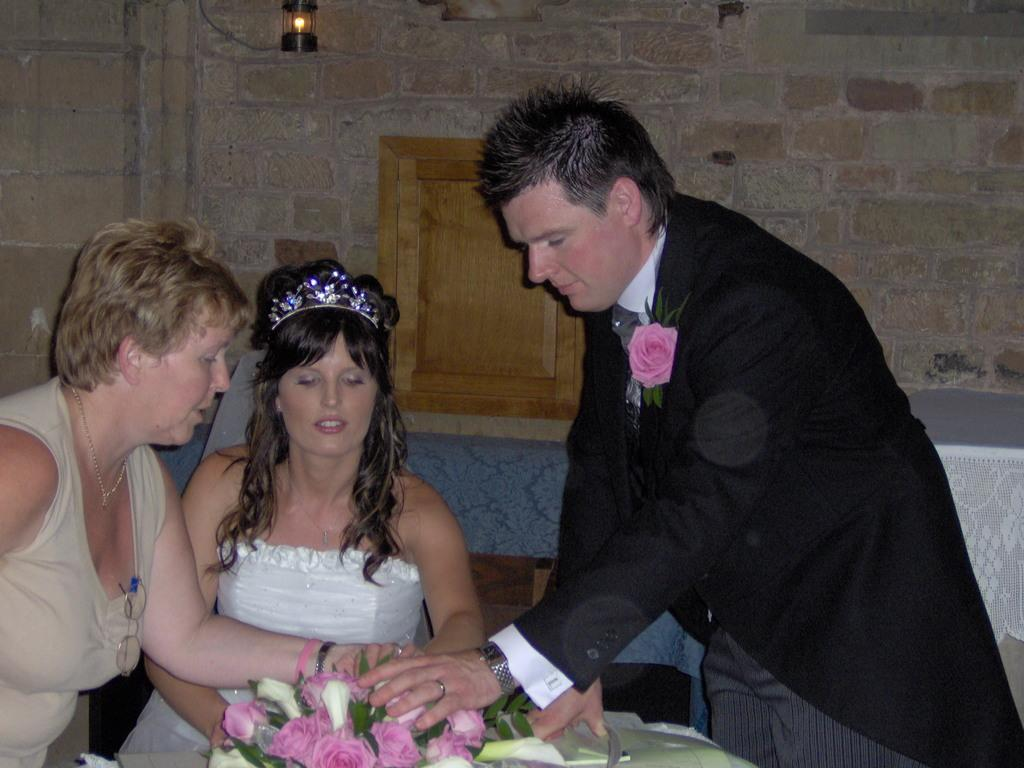Who or what can be seen in the image? There are people in the image. What type of flora is present in the image? There are flowers in the image. What is the nature of the wall in the image? There is a wall with objects in the image. Where are the objects located in the image? There are objects on the right side of the image. What is the color of one of the objects in the image? There is a blue colored object in the image. Can you see a tiger walking in the image? No, there is no tiger present in the image. Is there a boy playing with the objects on the right side of the image? The provided facts do not mention a boy, so we cannot confirm his presence in the image. 